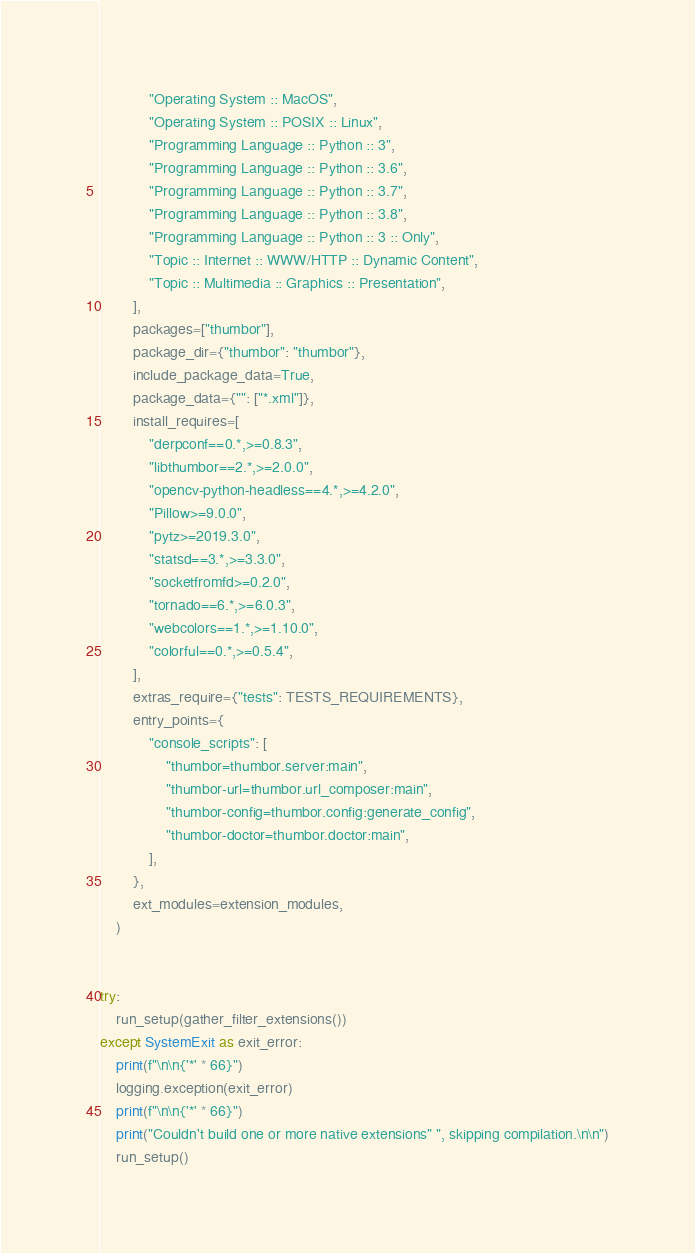Convert code to text. <code><loc_0><loc_0><loc_500><loc_500><_Python_>            "Operating System :: MacOS",
            "Operating System :: POSIX :: Linux",
            "Programming Language :: Python :: 3",
            "Programming Language :: Python :: 3.6",
            "Programming Language :: Python :: 3.7",
            "Programming Language :: Python :: 3.8",
            "Programming Language :: Python :: 3 :: Only",
            "Topic :: Internet :: WWW/HTTP :: Dynamic Content",
            "Topic :: Multimedia :: Graphics :: Presentation",
        ],
        packages=["thumbor"],
        package_dir={"thumbor": "thumbor"},
        include_package_data=True,
        package_data={"": ["*.xml"]},
        install_requires=[
            "derpconf==0.*,>=0.8.3",
            "libthumbor==2.*,>=2.0.0",
            "opencv-python-headless==4.*,>=4.2.0",
            "Pillow>=9.0.0",
            "pytz>=2019.3.0",
            "statsd==3.*,>=3.3.0",
            "socketfromfd>=0.2.0",
            "tornado==6.*,>=6.0.3",
            "webcolors==1.*,>=1.10.0",
            "colorful==0.*,>=0.5.4",
        ],
        extras_require={"tests": TESTS_REQUIREMENTS},
        entry_points={
            "console_scripts": [
                "thumbor=thumbor.server:main",
                "thumbor-url=thumbor.url_composer:main",
                "thumbor-config=thumbor.config:generate_config",
                "thumbor-doctor=thumbor.doctor:main",
            ],
        },
        ext_modules=extension_modules,
    )


try:
    run_setup(gather_filter_extensions())
except SystemExit as exit_error:
    print(f"\n\n{'*' * 66}")
    logging.exception(exit_error)
    print(f"\n\n{'*' * 66}")
    print("Couldn't build one or more native extensions" ", skipping compilation.\n\n")
    run_setup()
</code> 